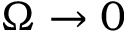<formula> <loc_0><loc_0><loc_500><loc_500>\Omega \rightarrow 0</formula> 